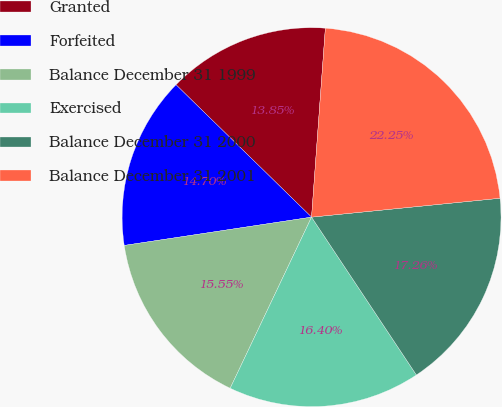Convert chart. <chart><loc_0><loc_0><loc_500><loc_500><pie_chart><fcel>Granted<fcel>Forfeited<fcel>Balance December 31 1999<fcel>Exercised<fcel>Balance December 31 2000<fcel>Balance December 31 2001<nl><fcel>13.85%<fcel>14.7%<fcel>15.55%<fcel>16.4%<fcel>17.26%<fcel>22.25%<nl></chart> 